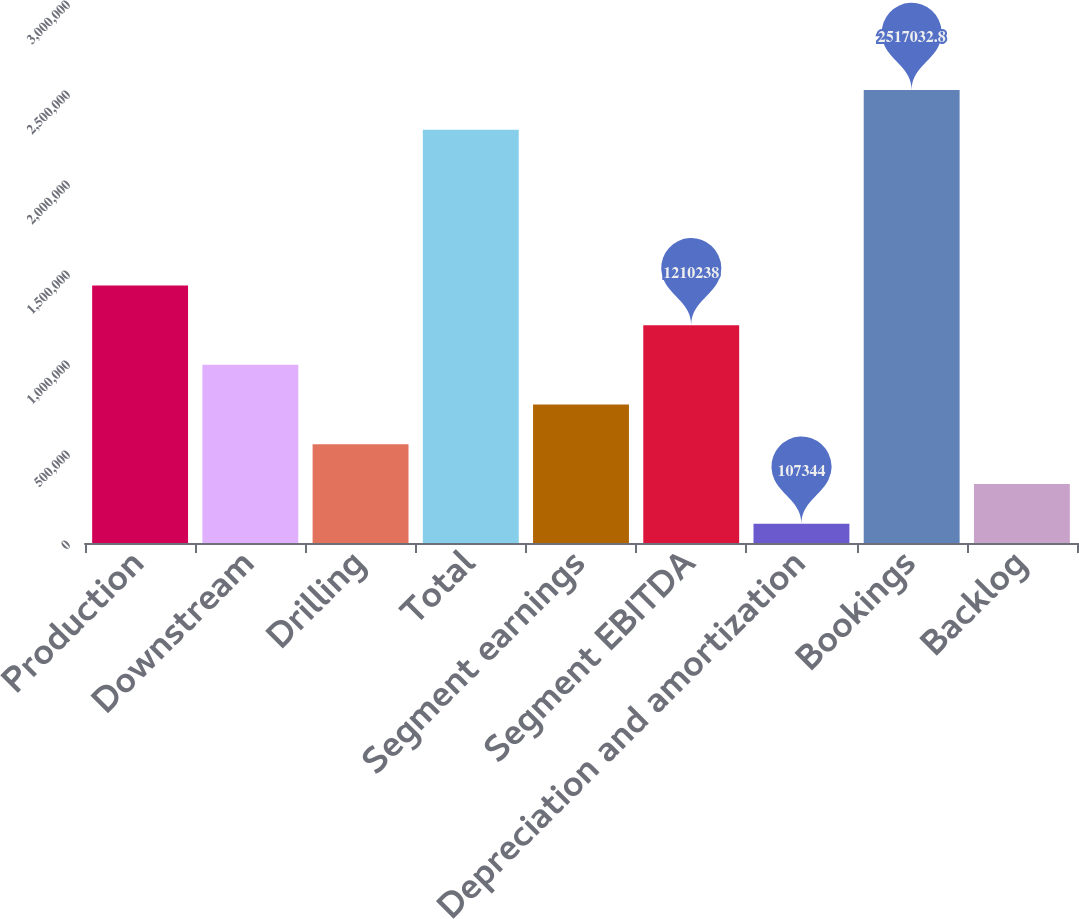<chart> <loc_0><loc_0><loc_500><loc_500><bar_chart><fcel>Production<fcel>Downstream<fcel>Drilling<fcel>Total<fcel>Segment earnings<fcel>Segment EBITDA<fcel>Depreciation and amortization<fcel>Bookings<fcel>Backlog<nl><fcel>1.43082e+06<fcel>989659<fcel>548502<fcel>2.29645e+06<fcel>769080<fcel>1.21024e+06<fcel>107344<fcel>2.51703e+06<fcel>327923<nl></chart> 